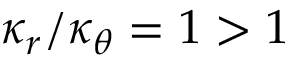Convert formula to latex. <formula><loc_0><loc_0><loc_500><loc_500>\kappa _ { r } / \kappa _ { \theta } = 1 > 1</formula> 